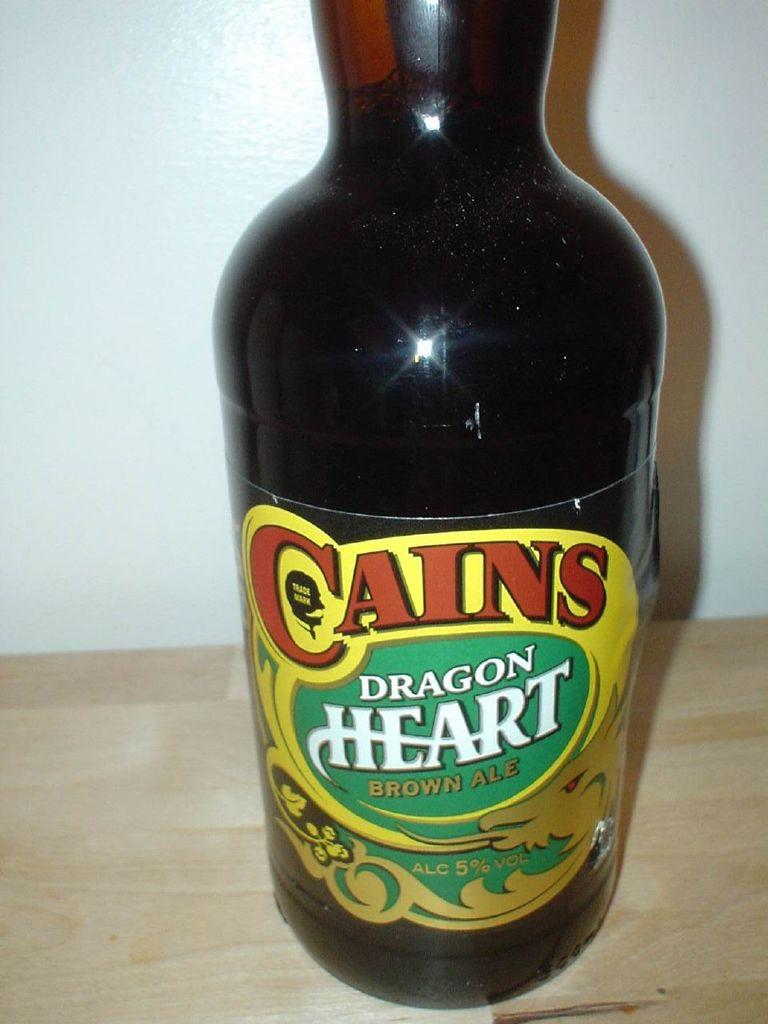<image>
Summarize the visual content of the image. A bottle of Cains Dragon Heart brown ale has a green, yellow, and red label. 